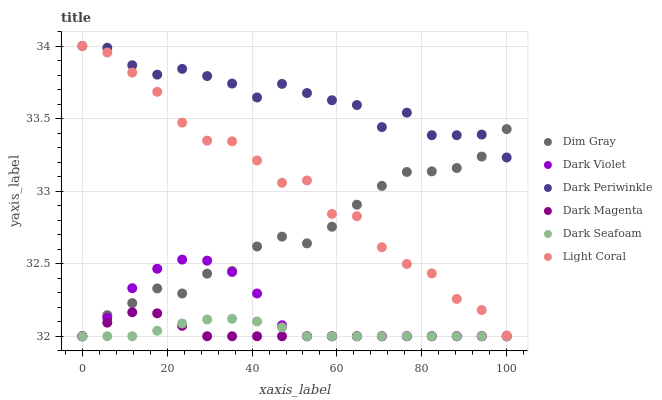Does Dark Magenta have the minimum area under the curve?
Answer yes or no. Yes. Does Dark Periwinkle have the maximum area under the curve?
Answer yes or no. Yes. Does Dark Violet have the minimum area under the curve?
Answer yes or no. No. Does Dark Violet have the maximum area under the curve?
Answer yes or no. No. Is Dark Seafoam the smoothest?
Answer yes or no. Yes. Is Light Coral the roughest?
Answer yes or no. Yes. Is Dark Magenta the smoothest?
Answer yes or no. No. Is Dark Magenta the roughest?
Answer yes or no. No. Does Dim Gray have the lowest value?
Answer yes or no. Yes. Does Light Coral have the lowest value?
Answer yes or no. No. Does Dark Periwinkle have the highest value?
Answer yes or no. Yes. Does Dark Magenta have the highest value?
Answer yes or no. No. Is Dark Seafoam less than Dark Periwinkle?
Answer yes or no. Yes. Is Dark Periwinkle greater than Dark Seafoam?
Answer yes or no. Yes. Does Dark Seafoam intersect Dim Gray?
Answer yes or no. Yes. Is Dark Seafoam less than Dim Gray?
Answer yes or no. No. Is Dark Seafoam greater than Dim Gray?
Answer yes or no. No. Does Dark Seafoam intersect Dark Periwinkle?
Answer yes or no. No. 